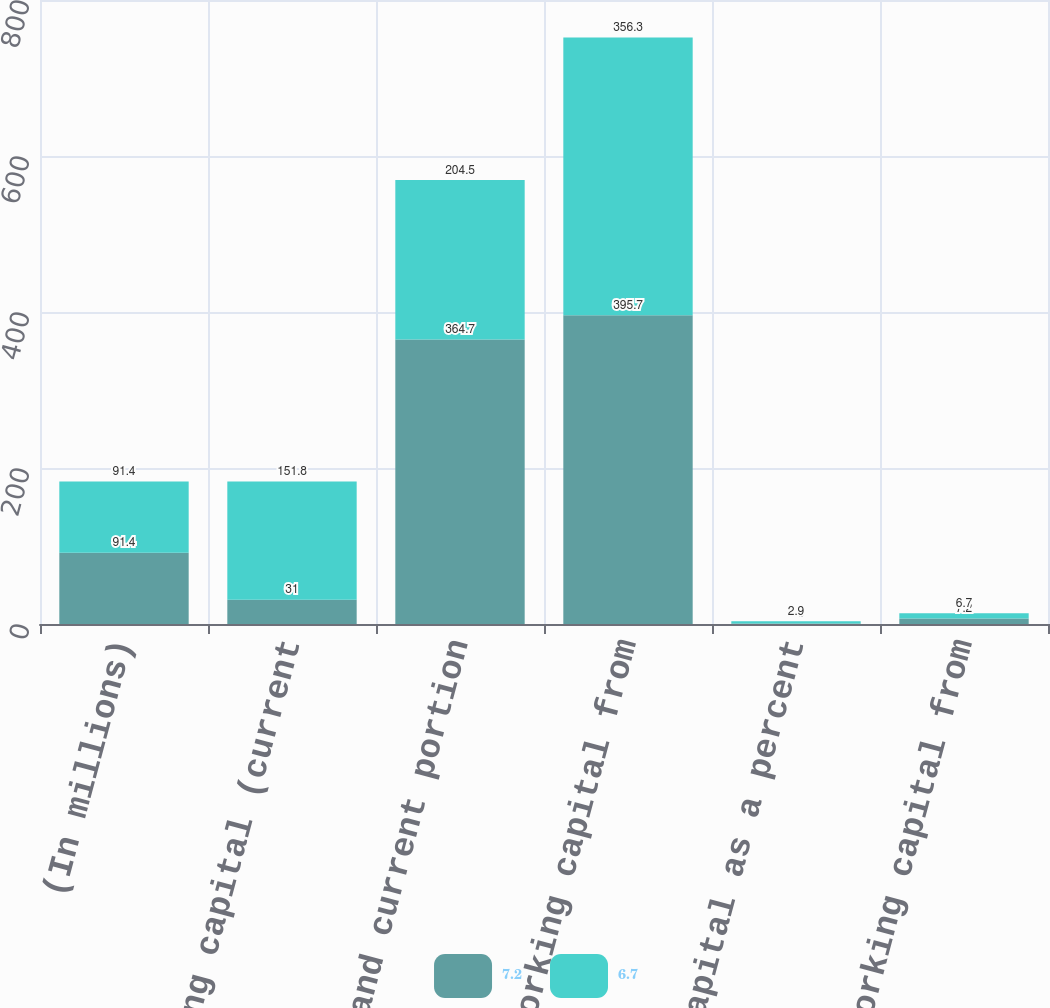Convert chart to OTSL. <chart><loc_0><loc_0><loc_500><loc_500><stacked_bar_chart><ecel><fcel>(In millions)<fcel>(A) Working capital (current<fcel>Short-term and current portion<fcel>(B) Working capital from<fcel>Working capital as a percent<fcel>Working capital from<nl><fcel>7.2<fcel>91.4<fcel>31<fcel>364.7<fcel>395.7<fcel>0.6<fcel>7.2<nl><fcel>6.7<fcel>91.4<fcel>151.8<fcel>204.5<fcel>356.3<fcel>2.9<fcel>6.7<nl></chart> 